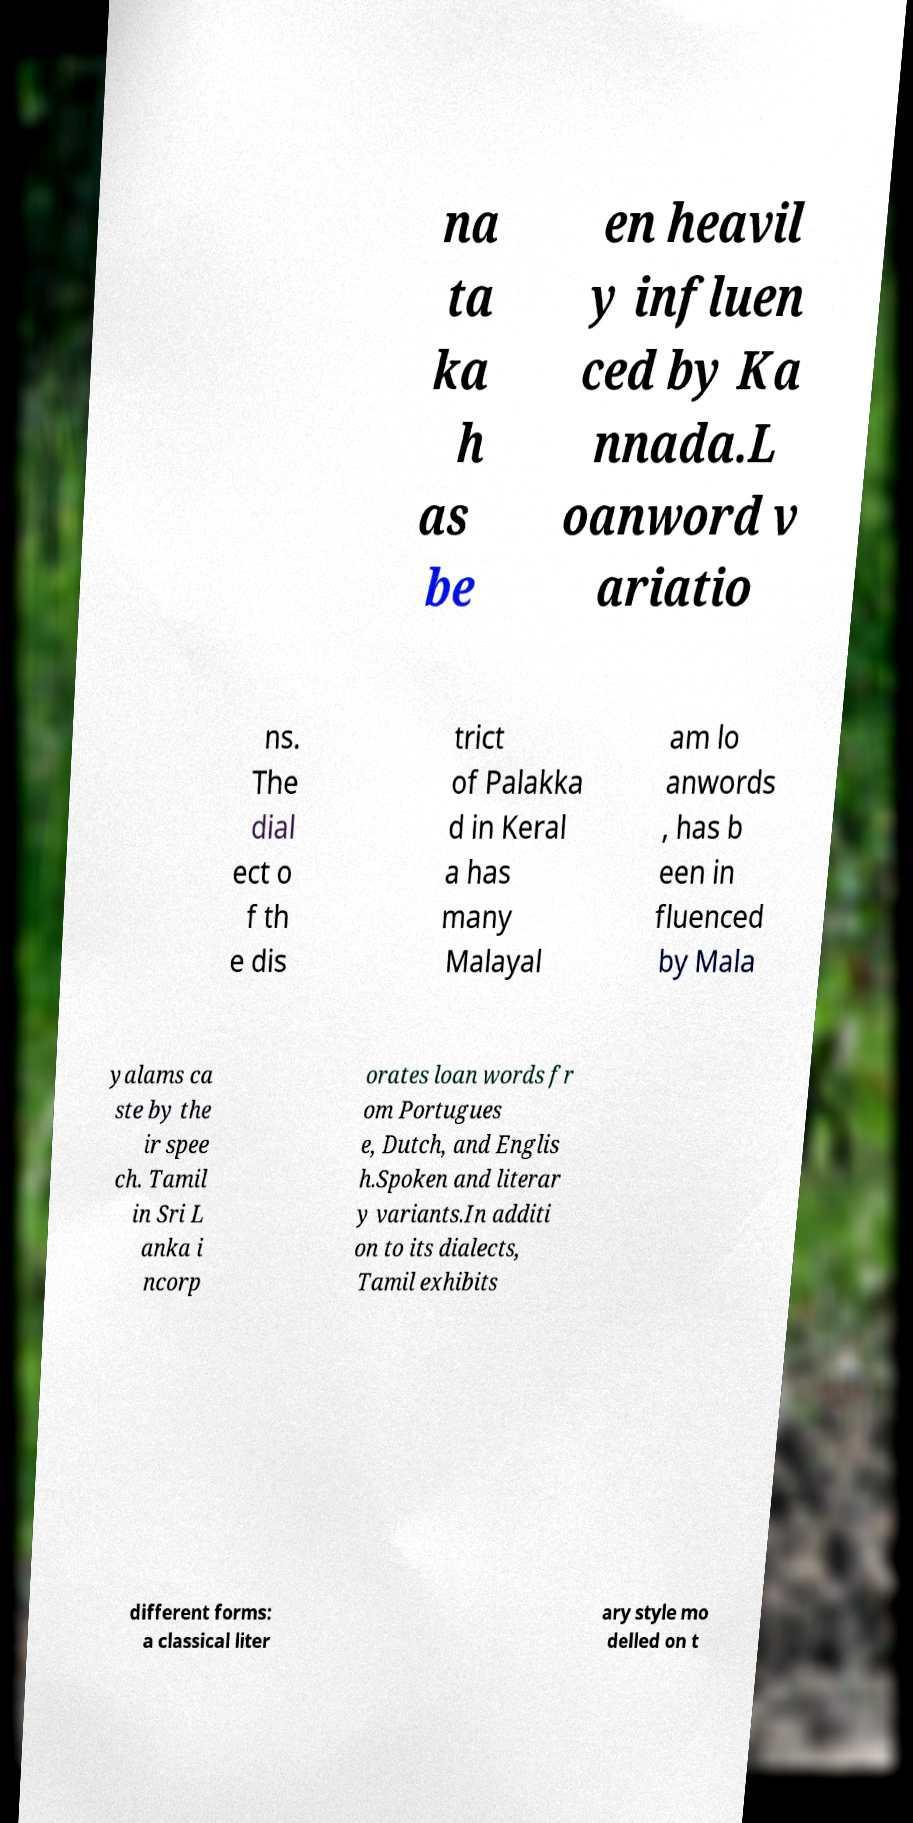Can you accurately transcribe the text from the provided image for me? na ta ka h as be en heavil y influen ced by Ka nnada.L oanword v ariatio ns. The dial ect o f th e dis trict of Palakka d in Keral a has many Malayal am lo anwords , has b een in fluenced by Mala yalams ca ste by the ir spee ch. Tamil in Sri L anka i ncorp orates loan words fr om Portugues e, Dutch, and Englis h.Spoken and literar y variants.In additi on to its dialects, Tamil exhibits different forms: a classical liter ary style mo delled on t 